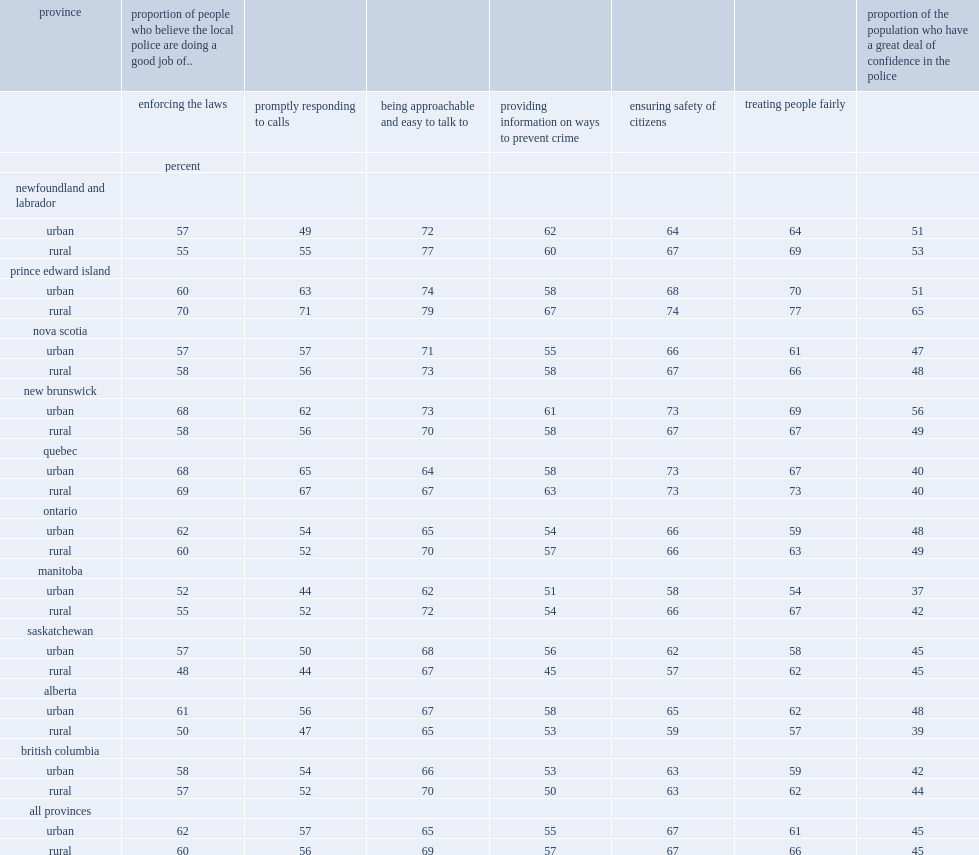What was the percentage of canadians who said they had a great deal of confidence in their local police? 45.0. Who were less likely to report having a great deal of confidence in their local police,those residing in rural areas of alberta or those residing in urban areas? Rural. Who were more likely to report having a great deal of confidence in their local police,those residing in rural areas of prince edward island or their urban counterparts? Rural. Who were less likely to say their local police was doing a good job in terms of enforcing the laws in alberta,residents of rural areas or their urban counterparts? Rural. Who were less likely to rate favourably their local police in terms of enforcing the laws, residents of rural areas in saskatchewan or their urban counterparts? Rural. 